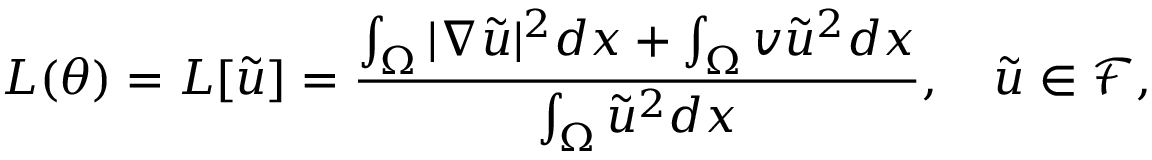Convert formula to latex. <formula><loc_0><loc_0><loc_500><loc_500>L ( \theta ) = L [ \tilde { u } ] = \frac { \int _ { \Omega } | \nabla \tilde { u } | ^ { 2 } d x + \int _ { \Omega } v \tilde { u } ^ { 2 } d x } { \int _ { \Omega } \tilde { u } ^ { 2 } d x } , \quad \tilde { u } \in \mathcal { F } ,</formula> 